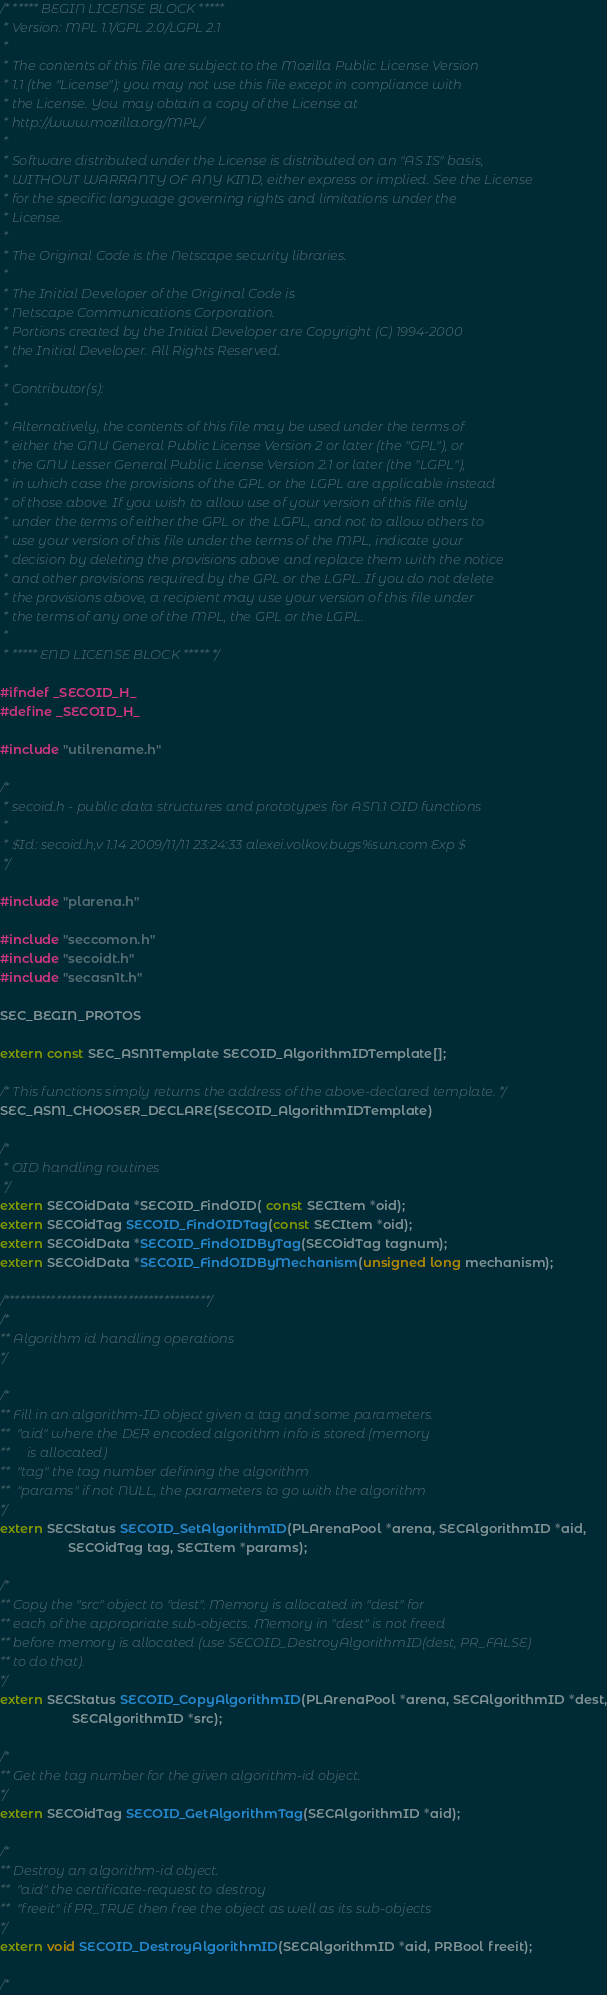Convert code to text. <code><loc_0><loc_0><loc_500><loc_500><_C_>/* ***** BEGIN LICENSE BLOCK *****
 * Version: MPL 1.1/GPL 2.0/LGPL 2.1
 *
 * The contents of this file are subject to the Mozilla Public License Version
 * 1.1 (the "License"); you may not use this file except in compliance with
 * the License. You may obtain a copy of the License at
 * http://www.mozilla.org/MPL/
 *
 * Software distributed under the License is distributed on an "AS IS" basis,
 * WITHOUT WARRANTY OF ANY KIND, either express or implied. See the License
 * for the specific language governing rights and limitations under the
 * License.
 *
 * The Original Code is the Netscape security libraries.
 *
 * The Initial Developer of the Original Code is
 * Netscape Communications Corporation.
 * Portions created by the Initial Developer are Copyright (C) 1994-2000
 * the Initial Developer. All Rights Reserved.
 *
 * Contributor(s):
 *
 * Alternatively, the contents of this file may be used under the terms of
 * either the GNU General Public License Version 2 or later (the "GPL"), or
 * the GNU Lesser General Public License Version 2.1 or later (the "LGPL"),
 * in which case the provisions of the GPL or the LGPL are applicable instead
 * of those above. If you wish to allow use of your version of this file only
 * under the terms of either the GPL or the LGPL, and not to allow others to
 * use your version of this file under the terms of the MPL, indicate your
 * decision by deleting the provisions above and replace them with the notice
 * and other provisions required by the GPL or the LGPL. If you do not delete
 * the provisions above, a recipient may use your version of this file under
 * the terms of any one of the MPL, the GPL or the LGPL.
 *
 * ***** END LICENSE BLOCK ***** */

#ifndef _SECOID_H_
#define _SECOID_H_

#include "utilrename.h"

/*
 * secoid.h - public data structures and prototypes for ASN.1 OID functions
 *
 * $Id: secoid.h,v 1.14 2009/11/11 23:24:33 alexei.volkov.bugs%sun.com Exp $
 */

#include "plarena.h"

#include "seccomon.h"
#include "secoidt.h"
#include "secasn1t.h"

SEC_BEGIN_PROTOS

extern const SEC_ASN1Template SECOID_AlgorithmIDTemplate[];

/* This functions simply returns the address of the above-declared template. */
SEC_ASN1_CHOOSER_DECLARE(SECOID_AlgorithmIDTemplate)

/*
 * OID handling routines
 */
extern SECOidData *SECOID_FindOID( const SECItem *oid);
extern SECOidTag SECOID_FindOIDTag(const SECItem *oid);
extern SECOidData *SECOID_FindOIDByTag(SECOidTag tagnum);
extern SECOidData *SECOID_FindOIDByMechanism(unsigned long mechanism);

/****************************************/
/*
** Algorithm id handling operations
*/

/*
** Fill in an algorithm-ID object given a tag and some parameters.
** 	"aid" where the DER encoded algorithm info is stored (memory
**	   is allocated)
**	"tag" the tag number defining the algorithm 
**	"params" if not NULL, the parameters to go with the algorithm
*/
extern SECStatus SECOID_SetAlgorithmID(PLArenaPool *arena, SECAlgorithmID *aid,
				   SECOidTag tag, SECItem *params);

/*
** Copy the "src" object to "dest". Memory is allocated in "dest" for
** each of the appropriate sub-objects. Memory in "dest" is not freed
** before memory is allocated (use SECOID_DestroyAlgorithmID(dest, PR_FALSE)
** to do that).
*/
extern SECStatus SECOID_CopyAlgorithmID(PLArenaPool *arena, SECAlgorithmID *dest,
				    SECAlgorithmID *src);

/*
** Get the tag number for the given algorithm-id object.
*/
extern SECOidTag SECOID_GetAlgorithmTag(SECAlgorithmID *aid);

/*
** Destroy an algorithm-id object.
**	"aid" the certificate-request to destroy
**	"freeit" if PR_TRUE then free the object as well as its sub-objects
*/
extern void SECOID_DestroyAlgorithmID(SECAlgorithmID *aid, PRBool freeit);

/*</code> 